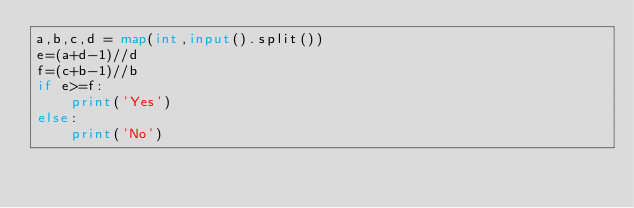Convert code to text. <code><loc_0><loc_0><loc_500><loc_500><_Python_>a,b,c,d = map(int,input().split())
e=(a+d-1)//d
f=(c+b-1)//b
if e>=f:
	print('Yes')
else:
	print('No')</code> 